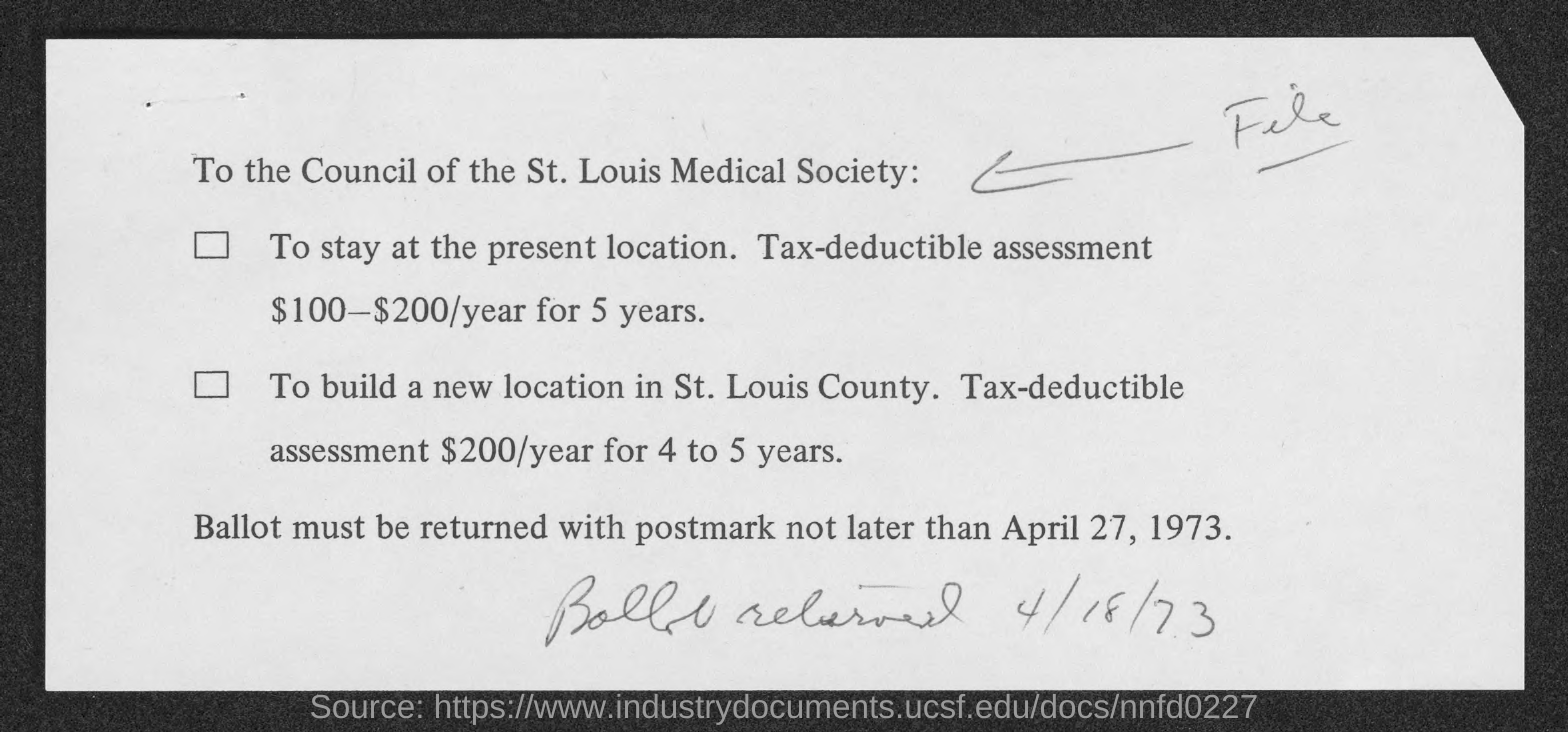Ballot must be returned with postmark not later than when?
Keep it short and to the point. April 27, 1973. 